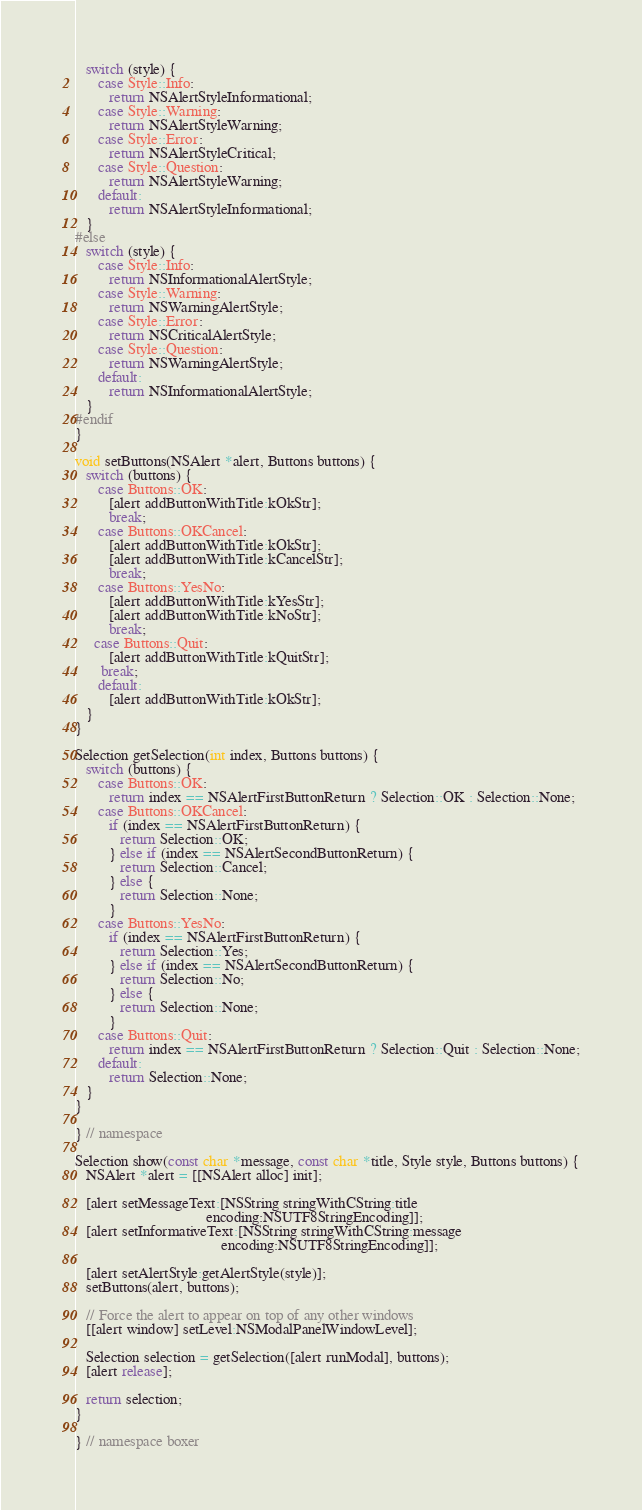Convert code to text. <code><loc_0><loc_0><loc_500><loc_500><_ObjectiveC_>   switch (style) {
      case Style::Info:
         return NSAlertStyleInformational;
      case Style::Warning:
         return NSAlertStyleWarning;
      case Style::Error:
         return NSAlertStyleCritical;
      case Style::Question:
         return NSAlertStyleWarning;
      default:
         return NSAlertStyleInformational;
   }
#else
   switch (style) {
      case Style::Info:
         return NSInformationalAlertStyle;
      case Style::Warning:
         return NSWarningAlertStyle;
      case Style::Error:
         return NSCriticalAlertStyle;
      case Style::Question:
         return NSWarningAlertStyle;
      default:
         return NSInformationalAlertStyle;
   }
#endif
}

void setButtons(NSAlert *alert, Buttons buttons) {
   switch (buttons) {
      case Buttons::OK:
         [alert addButtonWithTitle:kOkStr];
         break;
      case Buttons::OKCancel:
         [alert addButtonWithTitle:kOkStr];
         [alert addButtonWithTitle:kCancelStr];
         break;
      case Buttons::YesNo:
         [alert addButtonWithTitle:kYesStr];
         [alert addButtonWithTitle:kNoStr];
         break;
     case Buttons::Quit:
         [alert addButtonWithTitle:kQuitStr];
       break;
      default:
         [alert addButtonWithTitle:kOkStr];
   }
}

Selection getSelection(int index, Buttons buttons) {
   switch (buttons) {
      case Buttons::OK:
         return index == NSAlertFirstButtonReturn ? Selection::OK : Selection::None;
      case Buttons::OKCancel:
         if (index == NSAlertFirstButtonReturn) {
            return Selection::OK;
         } else if (index == NSAlertSecondButtonReturn) {
            return Selection::Cancel;
         } else {
            return Selection::None;
         }
      case Buttons::YesNo:
         if (index == NSAlertFirstButtonReturn) {
            return Selection::Yes;
         } else if (index == NSAlertSecondButtonReturn) {
            return Selection::No;
         } else {
            return Selection::None;
         }
      case Buttons::Quit:
         return index == NSAlertFirstButtonReturn ? Selection::Quit : Selection::None;
      default:
         return Selection::None;
   }
}

} // namespace

Selection show(const char *message, const char *title, Style style, Buttons buttons) {
   NSAlert *alert = [[NSAlert alloc] init];

   [alert setMessageText:[NSString stringWithCString:title
                                   encoding:NSUTF8StringEncoding]];
   [alert setInformativeText:[NSString stringWithCString:message
                                       encoding:NSUTF8StringEncoding]];

   [alert setAlertStyle:getAlertStyle(style)];
   setButtons(alert, buttons);

   // Force the alert to appear on top of any other windows
   [[alert window] setLevel:NSModalPanelWindowLevel];

   Selection selection = getSelection([alert runModal], buttons);
   [alert release];

   return selection;
}

} // namespace boxer
</code> 